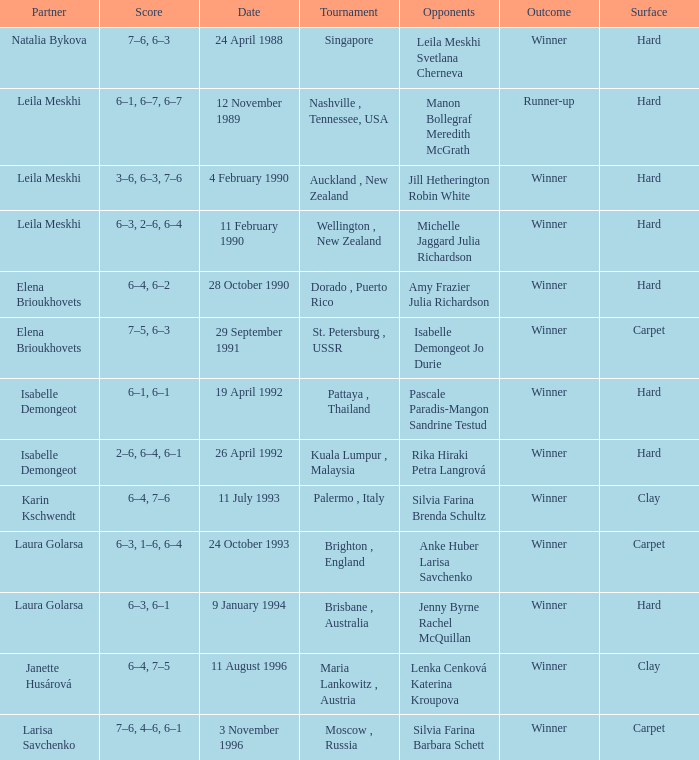On what Date was the Score 6–4, 6–2? 28 October 1990. 